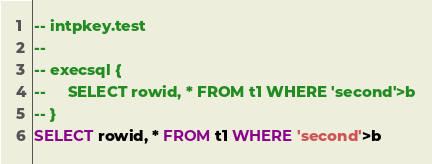<code> <loc_0><loc_0><loc_500><loc_500><_SQL_>-- intpkey.test
-- 
-- execsql {
--     SELECT rowid, * FROM t1 WHERE 'second'>b
-- }
SELECT rowid, * FROM t1 WHERE 'second'>b</code> 